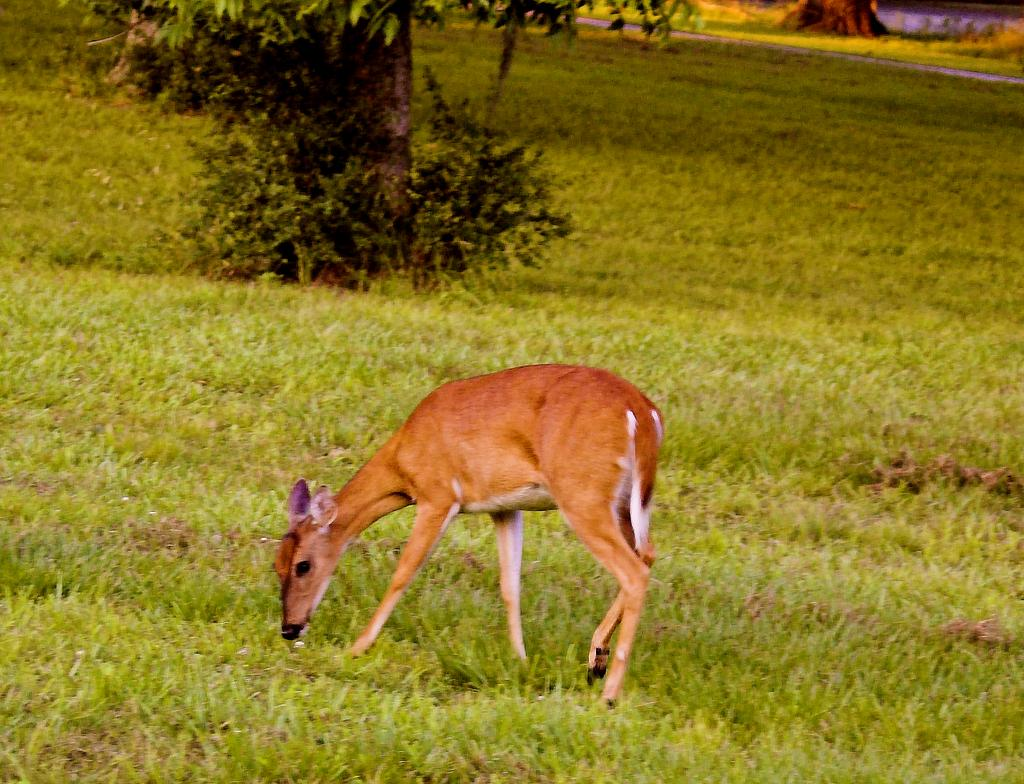What is the main setting of the image? There is an open grass ground in the image. What can be seen in the front of the grass ground? There is a brown-colored door standing in the front. What is visible in the background of the image? There are plants and a tree in the background of the image. What type of mountain can be seen in the background of the image? There is no mountain present in the image; it features an open grass ground, a brown-colored door, and plants and a tree in the background. Can you describe the branch of the tree in the image? There is no branch visible in the image, as only the tree trunk is shown. 